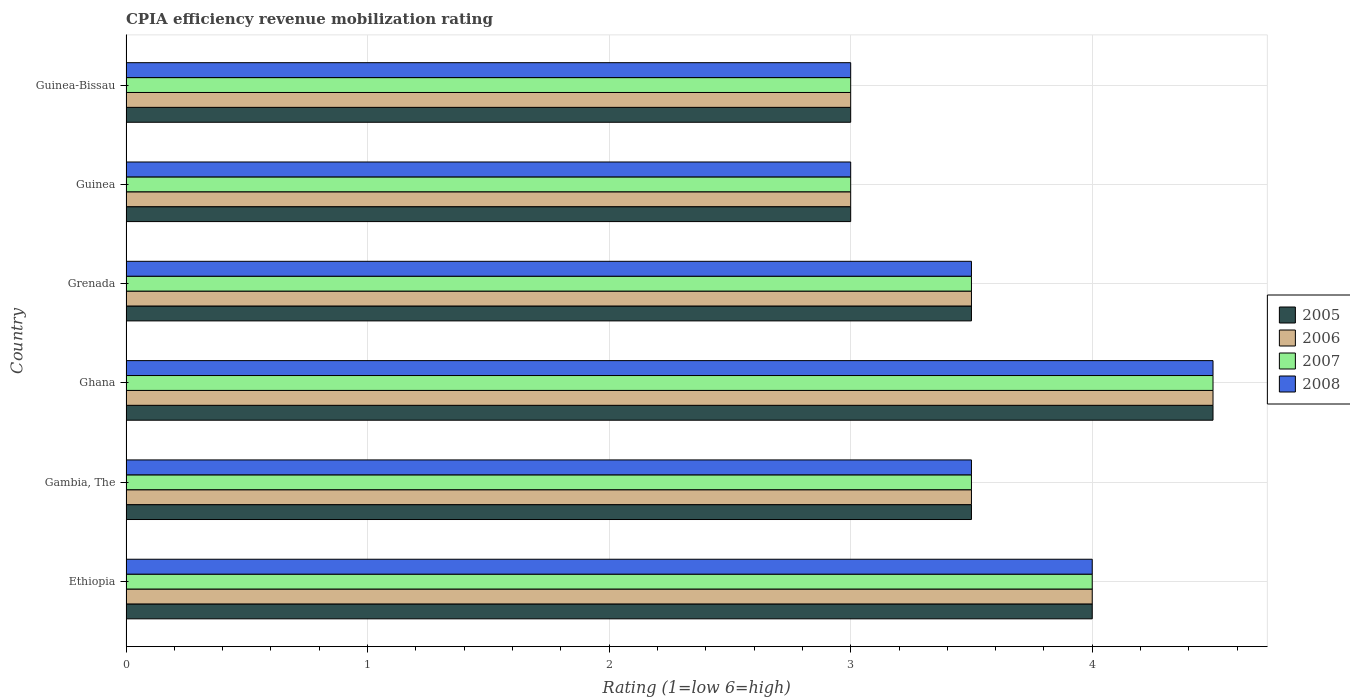How many bars are there on the 5th tick from the top?
Your response must be concise. 4. How many bars are there on the 1st tick from the bottom?
Your answer should be very brief. 4. What is the label of the 6th group of bars from the top?
Offer a terse response. Ethiopia. Across all countries, what is the maximum CPIA rating in 2007?
Keep it short and to the point. 4.5. Across all countries, what is the minimum CPIA rating in 2006?
Your answer should be very brief. 3. In which country was the CPIA rating in 2007 minimum?
Your answer should be very brief. Guinea. What is the total CPIA rating in 2006 in the graph?
Ensure brevity in your answer.  21.5. What is the difference between the CPIA rating in 2005 in Ethiopia and that in Guinea-Bissau?
Give a very brief answer. 1. What is the difference between the CPIA rating in 2005 in Grenada and the CPIA rating in 2008 in Gambia, The?
Give a very brief answer. 0. What is the average CPIA rating in 2008 per country?
Provide a short and direct response. 3.58. What is the difference between the CPIA rating in 2005 and CPIA rating in 2007 in Grenada?
Provide a succinct answer. 0. In how many countries, is the CPIA rating in 2007 greater than 1.4 ?
Provide a short and direct response. 6. Is the difference between the CPIA rating in 2005 in Ethiopia and Grenada greater than the difference between the CPIA rating in 2007 in Ethiopia and Grenada?
Offer a terse response. No. Is the sum of the CPIA rating in 2008 in Gambia, The and Ghana greater than the maximum CPIA rating in 2007 across all countries?
Offer a very short reply. Yes. What does the 4th bar from the top in Grenada represents?
Provide a succinct answer. 2005. Is it the case that in every country, the sum of the CPIA rating in 2008 and CPIA rating in 2007 is greater than the CPIA rating in 2006?
Keep it short and to the point. Yes. How many bars are there?
Your answer should be compact. 24. Are all the bars in the graph horizontal?
Your answer should be compact. Yes. How many countries are there in the graph?
Provide a succinct answer. 6. What is the difference between two consecutive major ticks on the X-axis?
Your answer should be very brief. 1. Are the values on the major ticks of X-axis written in scientific E-notation?
Give a very brief answer. No. Does the graph contain grids?
Your answer should be compact. Yes. Where does the legend appear in the graph?
Your answer should be compact. Center right. What is the title of the graph?
Your answer should be compact. CPIA efficiency revenue mobilization rating. What is the Rating (1=low 6=high) in 2007 in Ethiopia?
Your response must be concise. 4. What is the Rating (1=low 6=high) in 2005 in Gambia, The?
Give a very brief answer. 3.5. What is the Rating (1=low 6=high) of 2008 in Gambia, The?
Keep it short and to the point. 3.5. What is the Rating (1=low 6=high) of 2005 in Ghana?
Your answer should be very brief. 4.5. What is the Rating (1=low 6=high) in 2006 in Ghana?
Provide a succinct answer. 4.5. What is the Rating (1=low 6=high) in 2008 in Ghana?
Provide a succinct answer. 4.5. What is the Rating (1=low 6=high) in 2005 in Grenada?
Keep it short and to the point. 3.5. What is the Rating (1=low 6=high) in 2005 in Guinea?
Your response must be concise. 3. What is the Rating (1=low 6=high) of 2007 in Guinea?
Make the answer very short. 3. What is the Rating (1=low 6=high) of 2008 in Guinea?
Your answer should be very brief. 3. What is the Rating (1=low 6=high) of 2008 in Guinea-Bissau?
Provide a succinct answer. 3. Across all countries, what is the maximum Rating (1=low 6=high) of 2006?
Provide a succinct answer. 4.5. Across all countries, what is the maximum Rating (1=low 6=high) in 2007?
Ensure brevity in your answer.  4.5. Across all countries, what is the maximum Rating (1=low 6=high) of 2008?
Ensure brevity in your answer.  4.5. Across all countries, what is the minimum Rating (1=low 6=high) in 2005?
Your answer should be very brief. 3. Across all countries, what is the minimum Rating (1=low 6=high) in 2006?
Your answer should be very brief. 3. Across all countries, what is the minimum Rating (1=low 6=high) of 2007?
Offer a terse response. 3. What is the total Rating (1=low 6=high) of 2007 in the graph?
Your answer should be very brief. 21.5. What is the total Rating (1=low 6=high) of 2008 in the graph?
Ensure brevity in your answer.  21.5. What is the difference between the Rating (1=low 6=high) of 2006 in Ethiopia and that in Gambia, The?
Keep it short and to the point. 0.5. What is the difference between the Rating (1=low 6=high) of 2007 in Ethiopia and that in Gambia, The?
Offer a very short reply. 0.5. What is the difference between the Rating (1=low 6=high) of 2008 in Ethiopia and that in Gambia, The?
Provide a succinct answer. 0.5. What is the difference between the Rating (1=low 6=high) of 2008 in Ethiopia and that in Ghana?
Your answer should be compact. -0.5. What is the difference between the Rating (1=low 6=high) of 2005 in Ethiopia and that in Grenada?
Provide a succinct answer. 0.5. What is the difference between the Rating (1=low 6=high) in 2007 in Ethiopia and that in Grenada?
Provide a short and direct response. 0.5. What is the difference between the Rating (1=low 6=high) in 2008 in Ethiopia and that in Grenada?
Keep it short and to the point. 0.5. What is the difference between the Rating (1=low 6=high) of 2005 in Ethiopia and that in Guinea?
Ensure brevity in your answer.  1. What is the difference between the Rating (1=low 6=high) of 2006 in Ethiopia and that in Guinea?
Provide a short and direct response. 1. What is the difference between the Rating (1=low 6=high) in 2007 in Ethiopia and that in Guinea?
Provide a succinct answer. 1. What is the difference between the Rating (1=low 6=high) in 2006 in Ethiopia and that in Guinea-Bissau?
Offer a very short reply. 1. What is the difference between the Rating (1=low 6=high) in 2007 in Ethiopia and that in Guinea-Bissau?
Your response must be concise. 1. What is the difference between the Rating (1=low 6=high) of 2005 in Gambia, The and that in Ghana?
Ensure brevity in your answer.  -1. What is the difference between the Rating (1=low 6=high) in 2005 in Gambia, The and that in Grenada?
Keep it short and to the point. 0. What is the difference between the Rating (1=low 6=high) of 2007 in Gambia, The and that in Grenada?
Provide a succinct answer. 0. What is the difference between the Rating (1=low 6=high) in 2008 in Gambia, The and that in Grenada?
Offer a very short reply. 0. What is the difference between the Rating (1=low 6=high) of 2007 in Gambia, The and that in Guinea?
Provide a succinct answer. 0.5. What is the difference between the Rating (1=low 6=high) in 2005 in Gambia, The and that in Guinea-Bissau?
Provide a short and direct response. 0.5. What is the difference between the Rating (1=low 6=high) of 2006 in Gambia, The and that in Guinea-Bissau?
Give a very brief answer. 0.5. What is the difference between the Rating (1=low 6=high) in 2005 in Ghana and that in Grenada?
Offer a very short reply. 1. What is the difference between the Rating (1=low 6=high) of 2006 in Ghana and that in Guinea?
Offer a very short reply. 1.5. What is the difference between the Rating (1=low 6=high) in 2007 in Ghana and that in Guinea?
Give a very brief answer. 1.5. What is the difference between the Rating (1=low 6=high) of 2008 in Ghana and that in Guinea?
Give a very brief answer. 1.5. What is the difference between the Rating (1=low 6=high) in 2005 in Ghana and that in Guinea-Bissau?
Your response must be concise. 1.5. What is the difference between the Rating (1=low 6=high) in 2008 in Ghana and that in Guinea-Bissau?
Your response must be concise. 1.5. What is the difference between the Rating (1=low 6=high) in 2005 in Grenada and that in Guinea?
Provide a short and direct response. 0.5. What is the difference between the Rating (1=low 6=high) of 2007 in Grenada and that in Guinea?
Offer a very short reply. 0.5. What is the difference between the Rating (1=low 6=high) in 2008 in Grenada and that in Guinea?
Your answer should be very brief. 0.5. What is the difference between the Rating (1=low 6=high) in 2006 in Grenada and that in Guinea-Bissau?
Keep it short and to the point. 0.5. What is the difference between the Rating (1=low 6=high) of 2005 in Guinea and that in Guinea-Bissau?
Make the answer very short. 0. What is the difference between the Rating (1=low 6=high) of 2006 in Guinea and that in Guinea-Bissau?
Ensure brevity in your answer.  0. What is the difference between the Rating (1=low 6=high) in 2007 in Guinea and that in Guinea-Bissau?
Provide a short and direct response. 0. What is the difference between the Rating (1=low 6=high) of 2008 in Guinea and that in Guinea-Bissau?
Keep it short and to the point. 0. What is the difference between the Rating (1=low 6=high) of 2007 in Ethiopia and the Rating (1=low 6=high) of 2008 in Gambia, The?
Provide a short and direct response. 0.5. What is the difference between the Rating (1=low 6=high) of 2005 in Ethiopia and the Rating (1=low 6=high) of 2006 in Ghana?
Keep it short and to the point. -0.5. What is the difference between the Rating (1=low 6=high) in 2005 in Ethiopia and the Rating (1=low 6=high) in 2008 in Ghana?
Offer a terse response. -0.5. What is the difference between the Rating (1=low 6=high) in 2006 in Ethiopia and the Rating (1=low 6=high) in 2007 in Ghana?
Offer a very short reply. -0.5. What is the difference between the Rating (1=low 6=high) of 2006 in Ethiopia and the Rating (1=low 6=high) of 2008 in Ghana?
Your answer should be very brief. -0.5. What is the difference between the Rating (1=low 6=high) in 2005 in Ethiopia and the Rating (1=low 6=high) in 2008 in Grenada?
Offer a terse response. 0.5. What is the difference between the Rating (1=low 6=high) in 2006 in Ethiopia and the Rating (1=low 6=high) in 2008 in Grenada?
Your answer should be very brief. 0.5. What is the difference between the Rating (1=low 6=high) of 2007 in Ethiopia and the Rating (1=low 6=high) of 2008 in Grenada?
Offer a very short reply. 0.5. What is the difference between the Rating (1=low 6=high) of 2005 in Ethiopia and the Rating (1=low 6=high) of 2006 in Guinea?
Give a very brief answer. 1. What is the difference between the Rating (1=low 6=high) in 2005 in Ethiopia and the Rating (1=low 6=high) in 2007 in Guinea?
Your answer should be very brief. 1. What is the difference between the Rating (1=low 6=high) in 2005 in Ethiopia and the Rating (1=low 6=high) in 2008 in Guinea?
Offer a terse response. 1. What is the difference between the Rating (1=low 6=high) in 2007 in Ethiopia and the Rating (1=low 6=high) in 2008 in Guinea?
Provide a short and direct response. 1. What is the difference between the Rating (1=low 6=high) in 2005 in Ethiopia and the Rating (1=low 6=high) in 2007 in Guinea-Bissau?
Offer a very short reply. 1. What is the difference between the Rating (1=low 6=high) in 2005 in Gambia, The and the Rating (1=low 6=high) in 2008 in Ghana?
Your answer should be very brief. -1. What is the difference between the Rating (1=low 6=high) of 2006 in Gambia, The and the Rating (1=low 6=high) of 2008 in Ghana?
Offer a terse response. -1. What is the difference between the Rating (1=low 6=high) in 2007 in Gambia, The and the Rating (1=low 6=high) in 2008 in Ghana?
Your response must be concise. -1. What is the difference between the Rating (1=low 6=high) of 2005 in Gambia, The and the Rating (1=low 6=high) of 2006 in Grenada?
Keep it short and to the point. 0. What is the difference between the Rating (1=low 6=high) in 2006 in Gambia, The and the Rating (1=low 6=high) in 2007 in Grenada?
Give a very brief answer. 0. What is the difference between the Rating (1=low 6=high) in 2007 in Gambia, The and the Rating (1=low 6=high) in 2008 in Grenada?
Your response must be concise. 0. What is the difference between the Rating (1=low 6=high) in 2006 in Gambia, The and the Rating (1=low 6=high) in 2008 in Guinea?
Provide a succinct answer. 0.5. What is the difference between the Rating (1=low 6=high) of 2005 in Gambia, The and the Rating (1=low 6=high) of 2006 in Guinea-Bissau?
Your answer should be very brief. 0.5. What is the difference between the Rating (1=low 6=high) in 2005 in Gambia, The and the Rating (1=low 6=high) in 2007 in Guinea-Bissau?
Keep it short and to the point. 0.5. What is the difference between the Rating (1=low 6=high) of 2006 in Gambia, The and the Rating (1=low 6=high) of 2008 in Guinea-Bissau?
Your response must be concise. 0.5. What is the difference between the Rating (1=low 6=high) of 2007 in Gambia, The and the Rating (1=low 6=high) of 2008 in Guinea-Bissau?
Your response must be concise. 0.5. What is the difference between the Rating (1=low 6=high) in 2005 in Ghana and the Rating (1=low 6=high) in 2006 in Grenada?
Offer a very short reply. 1. What is the difference between the Rating (1=low 6=high) in 2005 in Ghana and the Rating (1=low 6=high) in 2008 in Grenada?
Offer a terse response. 1. What is the difference between the Rating (1=low 6=high) in 2006 in Ghana and the Rating (1=low 6=high) in 2008 in Grenada?
Make the answer very short. 1. What is the difference between the Rating (1=low 6=high) in 2006 in Ghana and the Rating (1=low 6=high) in 2007 in Guinea?
Offer a very short reply. 1.5. What is the difference between the Rating (1=low 6=high) in 2006 in Ghana and the Rating (1=low 6=high) in 2008 in Guinea?
Keep it short and to the point. 1.5. What is the difference between the Rating (1=low 6=high) of 2005 in Ghana and the Rating (1=low 6=high) of 2006 in Guinea-Bissau?
Your response must be concise. 1.5. What is the difference between the Rating (1=low 6=high) of 2006 in Ghana and the Rating (1=low 6=high) of 2007 in Guinea-Bissau?
Give a very brief answer. 1.5. What is the difference between the Rating (1=low 6=high) of 2007 in Ghana and the Rating (1=low 6=high) of 2008 in Guinea-Bissau?
Your answer should be compact. 1.5. What is the difference between the Rating (1=low 6=high) of 2005 in Grenada and the Rating (1=low 6=high) of 2008 in Guinea?
Ensure brevity in your answer.  0.5. What is the difference between the Rating (1=low 6=high) of 2006 in Grenada and the Rating (1=low 6=high) of 2008 in Guinea?
Make the answer very short. 0.5. What is the difference between the Rating (1=low 6=high) of 2005 in Grenada and the Rating (1=low 6=high) of 2006 in Guinea-Bissau?
Offer a very short reply. 0.5. What is the difference between the Rating (1=low 6=high) of 2005 in Grenada and the Rating (1=low 6=high) of 2007 in Guinea-Bissau?
Make the answer very short. 0.5. What is the difference between the Rating (1=low 6=high) of 2005 in Grenada and the Rating (1=low 6=high) of 2008 in Guinea-Bissau?
Offer a terse response. 0.5. What is the difference between the Rating (1=low 6=high) in 2006 in Grenada and the Rating (1=low 6=high) in 2007 in Guinea-Bissau?
Make the answer very short. 0.5. What is the difference between the Rating (1=low 6=high) in 2006 in Grenada and the Rating (1=low 6=high) in 2008 in Guinea-Bissau?
Make the answer very short. 0.5. What is the difference between the Rating (1=low 6=high) of 2007 in Grenada and the Rating (1=low 6=high) of 2008 in Guinea-Bissau?
Your response must be concise. 0.5. What is the difference between the Rating (1=low 6=high) of 2005 in Guinea and the Rating (1=low 6=high) of 2007 in Guinea-Bissau?
Keep it short and to the point. 0. What is the difference between the Rating (1=low 6=high) in 2006 in Guinea and the Rating (1=low 6=high) in 2007 in Guinea-Bissau?
Ensure brevity in your answer.  0. What is the difference between the Rating (1=low 6=high) in 2007 in Guinea and the Rating (1=low 6=high) in 2008 in Guinea-Bissau?
Your response must be concise. 0. What is the average Rating (1=low 6=high) in 2005 per country?
Give a very brief answer. 3.58. What is the average Rating (1=low 6=high) in 2006 per country?
Keep it short and to the point. 3.58. What is the average Rating (1=low 6=high) in 2007 per country?
Provide a succinct answer. 3.58. What is the average Rating (1=low 6=high) in 2008 per country?
Provide a short and direct response. 3.58. What is the difference between the Rating (1=low 6=high) in 2005 and Rating (1=low 6=high) in 2006 in Ethiopia?
Keep it short and to the point. 0. What is the difference between the Rating (1=low 6=high) in 2006 and Rating (1=low 6=high) in 2007 in Ethiopia?
Your answer should be very brief. 0. What is the difference between the Rating (1=low 6=high) of 2006 and Rating (1=low 6=high) of 2008 in Ethiopia?
Ensure brevity in your answer.  0. What is the difference between the Rating (1=low 6=high) of 2007 and Rating (1=low 6=high) of 2008 in Ethiopia?
Make the answer very short. 0. What is the difference between the Rating (1=low 6=high) in 2006 and Rating (1=low 6=high) in 2008 in Gambia, The?
Offer a terse response. 0. What is the difference between the Rating (1=low 6=high) of 2006 and Rating (1=low 6=high) of 2007 in Ghana?
Your answer should be compact. 0. What is the difference between the Rating (1=low 6=high) in 2007 and Rating (1=low 6=high) in 2008 in Ghana?
Offer a terse response. 0. What is the difference between the Rating (1=low 6=high) in 2005 and Rating (1=low 6=high) in 2006 in Grenada?
Make the answer very short. 0. What is the difference between the Rating (1=low 6=high) in 2005 and Rating (1=low 6=high) in 2008 in Grenada?
Offer a very short reply. 0. What is the difference between the Rating (1=low 6=high) of 2006 and Rating (1=low 6=high) of 2007 in Grenada?
Provide a short and direct response. 0. What is the difference between the Rating (1=low 6=high) of 2006 and Rating (1=low 6=high) of 2008 in Grenada?
Offer a very short reply. 0. What is the difference between the Rating (1=low 6=high) in 2007 and Rating (1=low 6=high) in 2008 in Grenada?
Offer a terse response. 0. What is the difference between the Rating (1=low 6=high) in 2005 and Rating (1=low 6=high) in 2007 in Guinea?
Your answer should be very brief. 0. What is the difference between the Rating (1=low 6=high) in 2006 and Rating (1=low 6=high) in 2008 in Guinea?
Offer a very short reply. 0. What is the difference between the Rating (1=low 6=high) of 2005 and Rating (1=low 6=high) of 2006 in Guinea-Bissau?
Ensure brevity in your answer.  0. What is the ratio of the Rating (1=low 6=high) of 2006 in Ethiopia to that in Gambia, The?
Your answer should be compact. 1.14. What is the ratio of the Rating (1=low 6=high) of 2006 in Ethiopia to that in Ghana?
Your answer should be compact. 0.89. What is the ratio of the Rating (1=low 6=high) in 2007 in Ethiopia to that in Ghana?
Make the answer very short. 0.89. What is the ratio of the Rating (1=low 6=high) of 2008 in Ethiopia to that in Ghana?
Ensure brevity in your answer.  0.89. What is the ratio of the Rating (1=low 6=high) in 2007 in Ethiopia to that in Grenada?
Ensure brevity in your answer.  1.14. What is the ratio of the Rating (1=low 6=high) in 2008 in Ethiopia to that in Grenada?
Make the answer very short. 1.14. What is the ratio of the Rating (1=low 6=high) of 2005 in Ethiopia to that in Guinea?
Keep it short and to the point. 1.33. What is the ratio of the Rating (1=low 6=high) in 2007 in Ethiopia to that in Guinea?
Make the answer very short. 1.33. What is the ratio of the Rating (1=low 6=high) in 2008 in Ethiopia to that in Guinea?
Your response must be concise. 1.33. What is the ratio of the Rating (1=low 6=high) in 2007 in Ethiopia to that in Guinea-Bissau?
Your answer should be compact. 1.33. What is the ratio of the Rating (1=low 6=high) in 2006 in Gambia, The to that in Ghana?
Ensure brevity in your answer.  0.78. What is the ratio of the Rating (1=low 6=high) of 2007 in Gambia, The to that in Ghana?
Give a very brief answer. 0.78. What is the ratio of the Rating (1=low 6=high) of 2006 in Gambia, The to that in Grenada?
Provide a short and direct response. 1. What is the ratio of the Rating (1=low 6=high) in 2005 in Gambia, The to that in Guinea?
Your response must be concise. 1.17. What is the ratio of the Rating (1=low 6=high) of 2007 in Gambia, The to that in Guinea?
Provide a short and direct response. 1.17. What is the ratio of the Rating (1=low 6=high) in 2008 in Gambia, The to that in Guinea?
Offer a very short reply. 1.17. What is the ratio of the Rating (1=low 6=high) in 2006 in Gambia, The to that in Guinea-Bissau?
Ensure brevity in your answer.  1.17. What is the ratio of the Rating (1=low 6=high) of 2008 in Gambia, The to that in Guinea-Bissau?
Offer a very short reply. 1.17. What is the ratio of the Rating (1=low 6=high) of 2005 in Ghana to that in Grenada?
Provide a succinct answer. 1.29. What is the ratio of the Rating (1=low 6=high) of 2006 in Ghana to that in Grenada?
Your answer should be compact. 1.29. What is the ratio of the Rating (1=low 6=high) in 2007 in Ghana to that in Grenada?
Your answer should be compact. 1.29. What is the ratio of the Rating (1=low 6=high) in 2007 in Ghana to that in Guinea?
Your response must be concise. 1.5. What is the ratio of the Rating (1=low 6=high) in 2005 in Grenada to that in Guinea?
Your answer should be very brief. 1.17. What is the ratio of the Rating (1=low 6=high) in 2007 in Grenada to that in Guinea?
Offer a very short reply. 1.17. What is the ratio of the Rating (1=low 6=high) in 2008 in Grenada to that in Guinea-Bissau?
Your response must be concise. 1.17. What is the ratio of the Rating (1=low 6=high) in 2008 in Guinea to that in Guinea-Bissau?
Your response must be concise. 1. What is the difference between the highest and the second highest Rating (1=low 6=high) of 2005?
Ensure brevity in your answer.  0.5. What is the difference between the highest and the second highest Rating (1=low 6=high) in 2006?
Give a very brief answer. 0.5. What is the difference between the highest and the second highest Rating (1=low 6=high) of 2007?
Offer a very short reply. 0.5. What is the difference between the highest and the second highest Rating (1=low 6=high) of 2008?
Your response must be concise. 0.5. What is the difference between the highest and the lowest Rating (1=low 6=high) of 2008?
Offer a terse response. 1.5. 